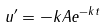Convert formula to latex. <formula><loc_0><loc_0><loc_500><loc_500>u ^ { \prime } = - k A e ^ { - k t }</formula> 